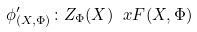Convert formula to latex. <formula><loc_0><loc_0><loc_500><loc_500>\phi ^ { \prime } _ { ( X , \Phi ) } \colon Z _ { \Phi } ( X ) \ x F ( X , \Phi )</formula> 